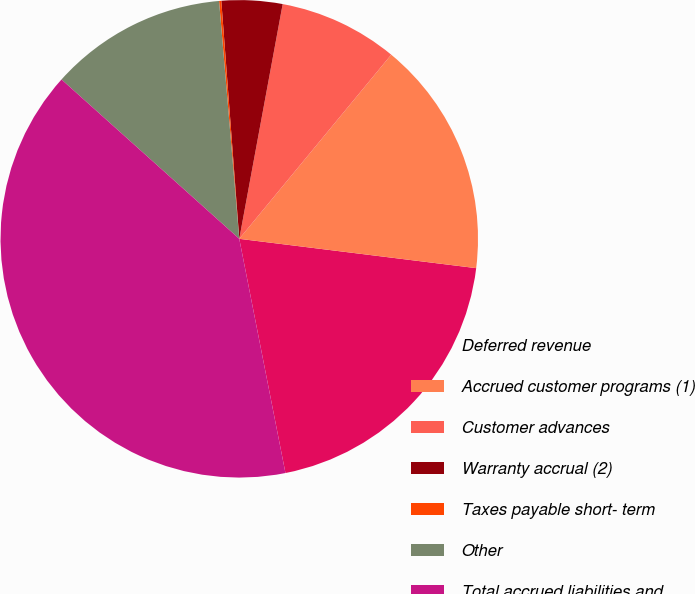Convert chart to OTSL. <chart><loc_0><loc_0><loc_500><loc_500><pie_chart><fcel>Deferred revenue<fcel>Accrued customer programs (1)<fcel>Customer advances<fcel>Warranty accrual (2)<fcel>Taxes payable short- term<fcel>Other<fcel>Total accrued liabilities and<nl><fcel>19.94%<fcel>15.98%<fcel>8.07%<fcel>4.11%<fcel>0.15%<fcel>12.02%<fcel>39.73%<nl></chart> 